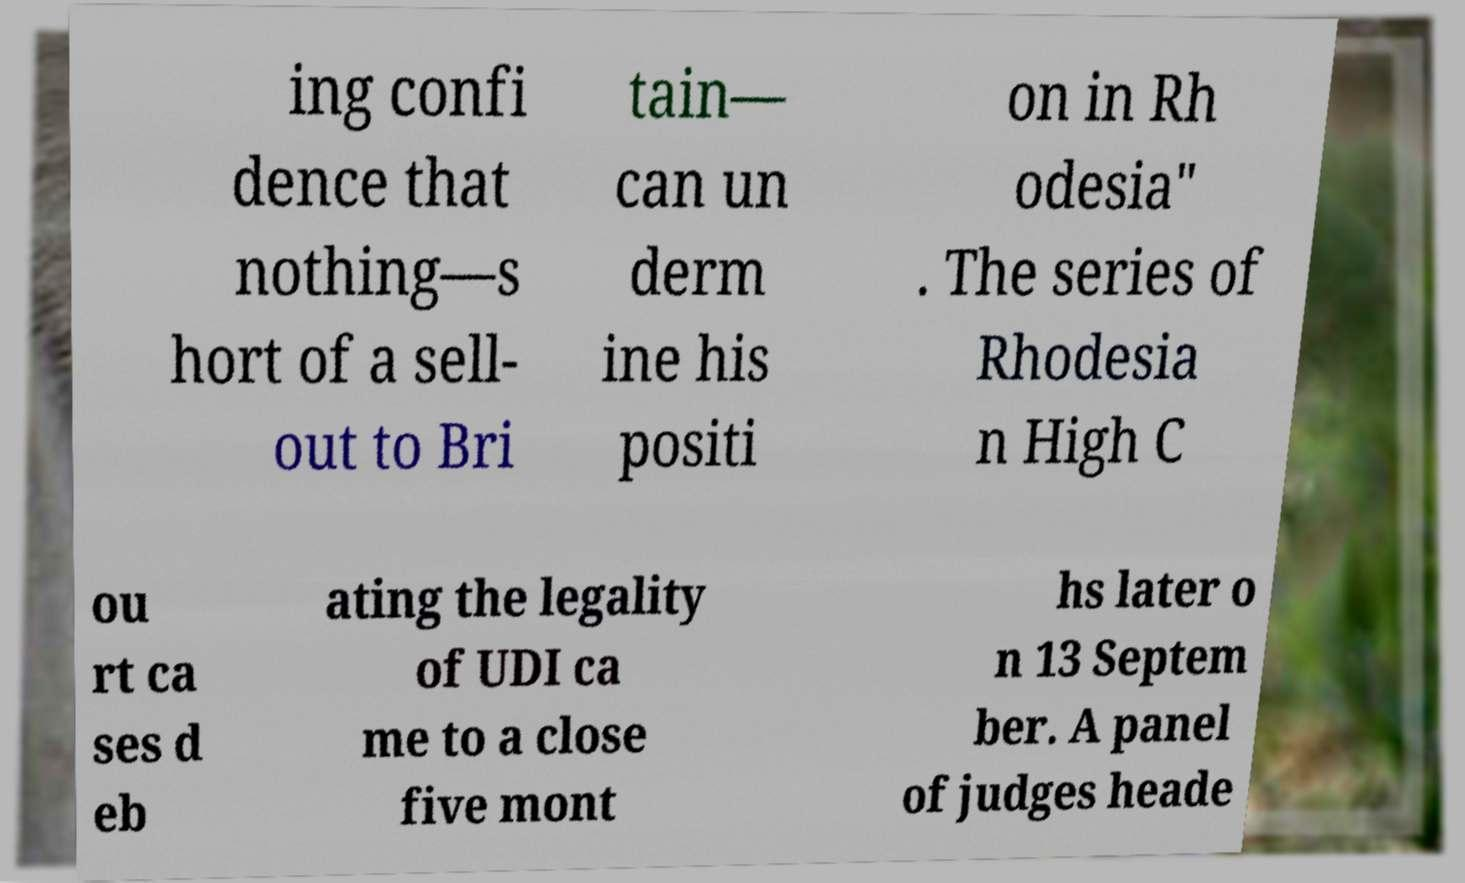Please read and relay the text visible in this image. What does it say? ing confi dence that nothing—s hort of a sell- out to Bri tain— can un derm ine his positi on in Rh odesia" . The series of Rhodesia n High C ou rt ca ses d eb ating the legality of UDI ca me to a close five mont hs later o n 13 Septem ber. A panel of judges heade 